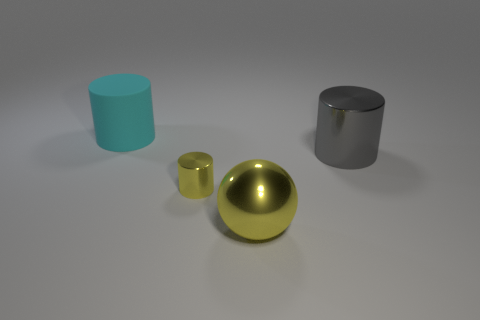Is there anything else that is the same size as the yellow metal cylinder?
Provide a succinct answer. No. Are there any other things that are the same shape as the large yellow object?
Your answer should be compact. No. There is a big thing to the left of the big sphere; how many yellow cylinders are in front of it?
Your answer should be very brief. 1. There is a object that is both behind the yellow sphere and in front of the big gray cylinder; what is its size?
Offer a very short reply. Small. Is the number of blue rubber objects greater than the number of matte things?
Provide a short and direct response. No. Is there a metallic cylinder of the same color as the big metal sphere?
Keep it short and to the point. Yes. There is a thing that is in front of the yellow metal cylinder; is it the same size as the cyan matte object?
Keep it short and to the point. Yes. Are there fewer large cyan cylinders than big metal objects?
Offer a very short reply. Yes. Is there a cyan thing that has the same material as the sphere?
Ensure brevity in your answer.  No. What shape is the large object in front of the large shiny cylinder?
Your response must be concise. Sphere. 